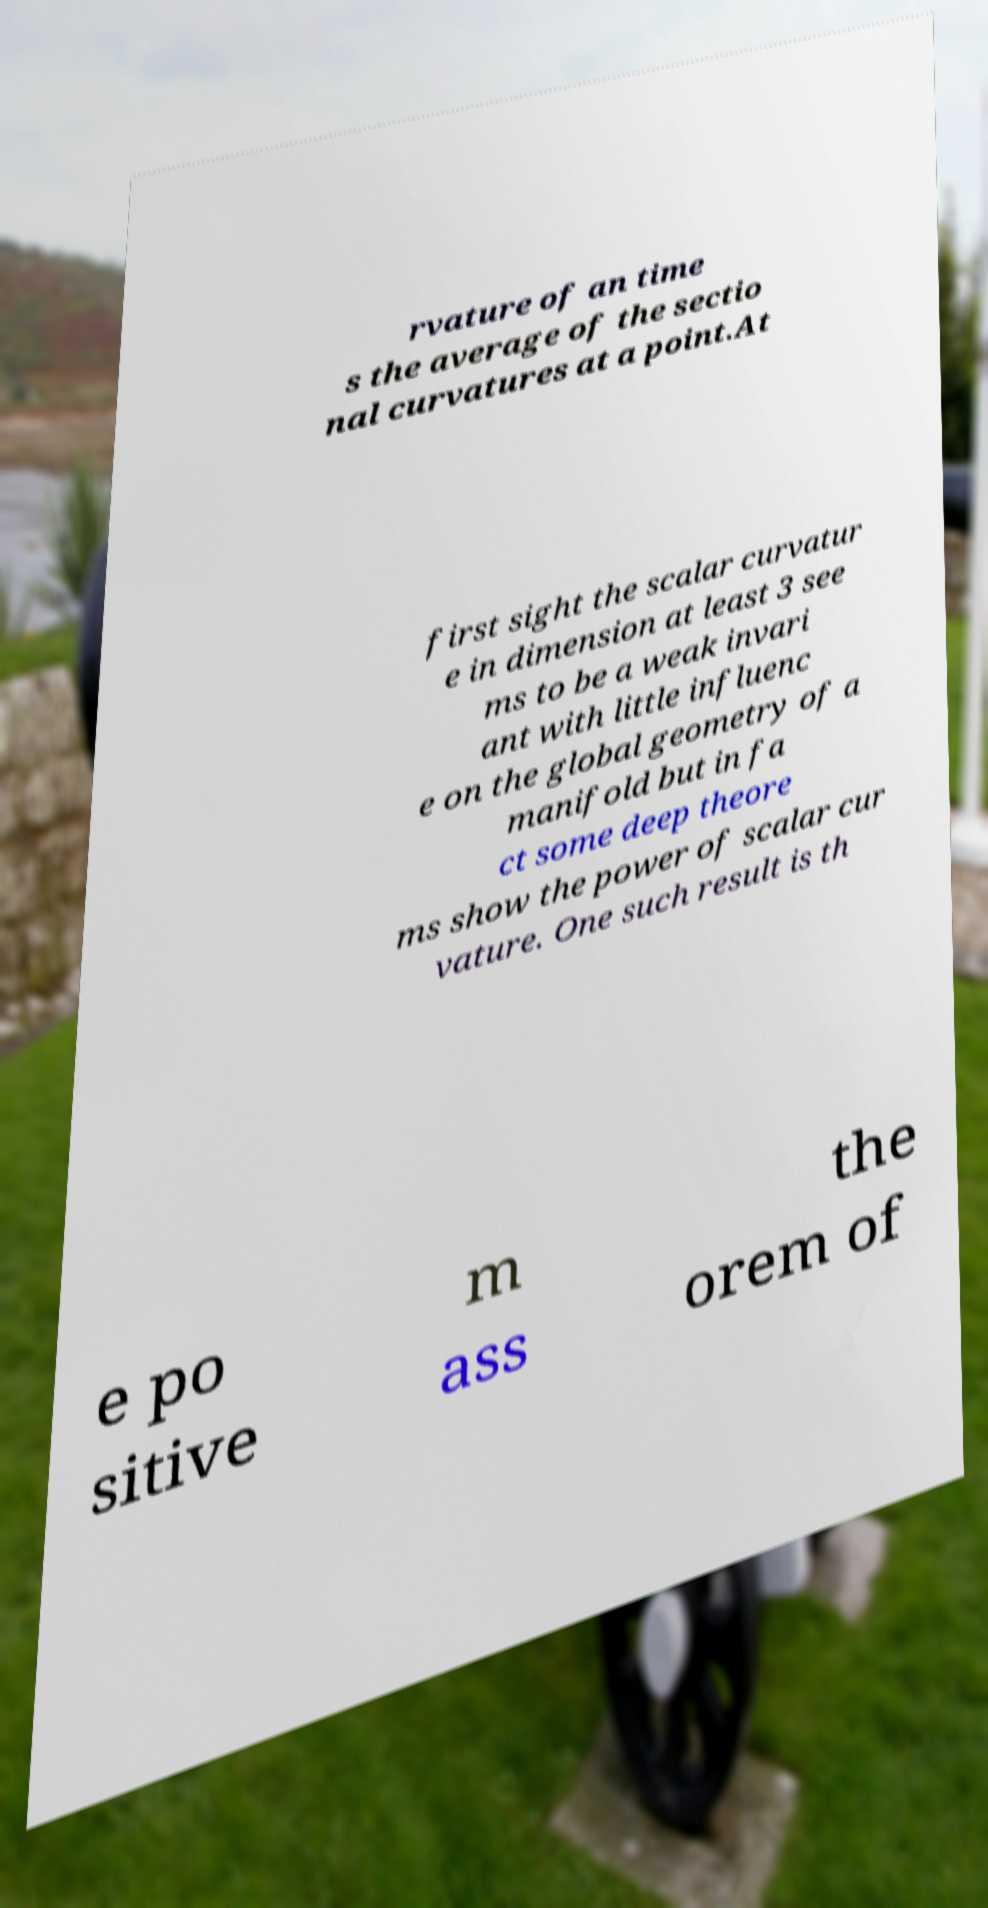I need the written content from this picture converted into text. Can you do that? rvature of an time s the average of the sectio nal curvatures at a point.At first sight the scalar curvatur e in dimension at least 3 see ms to be a weak invari ant with little influenc e on the global geometry of a manifold but in fa ct some deep theore ms show the power of scalar cur vature. One such result is th e po sitive m ass the orem of 